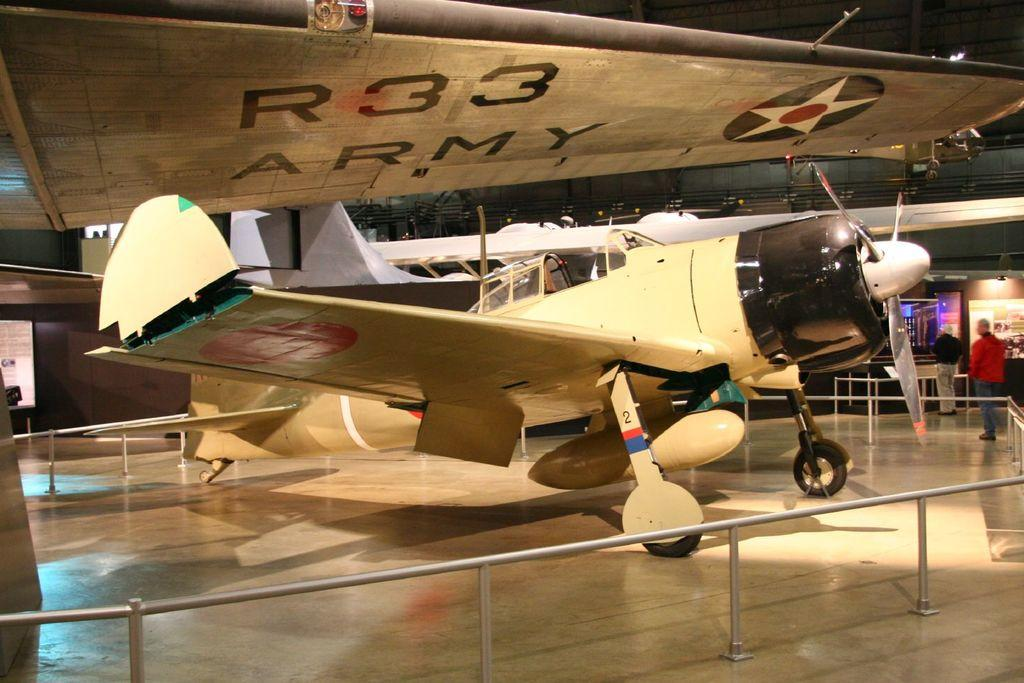What is the main subject of the picture? The main subject of the picture is an aircraft. What is surrounding the aircraft in the image? There is fencing around the aircraft. Are there any people visible in the image? Yes, there are two people standing on the path on the right side of the image. What type of canvas is being used to paint the snails in the image? There are no snails or canvas present in the image; it features an aircraft with fencing and two people on a path. 